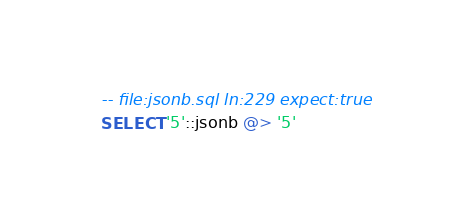<code> <loc_0><loc_0><loc_500><loc_500><_SQL_>-- file:jsonb.sql ln:229 expect:true
SELECT '5'::jsonb @> '5'
</code> 